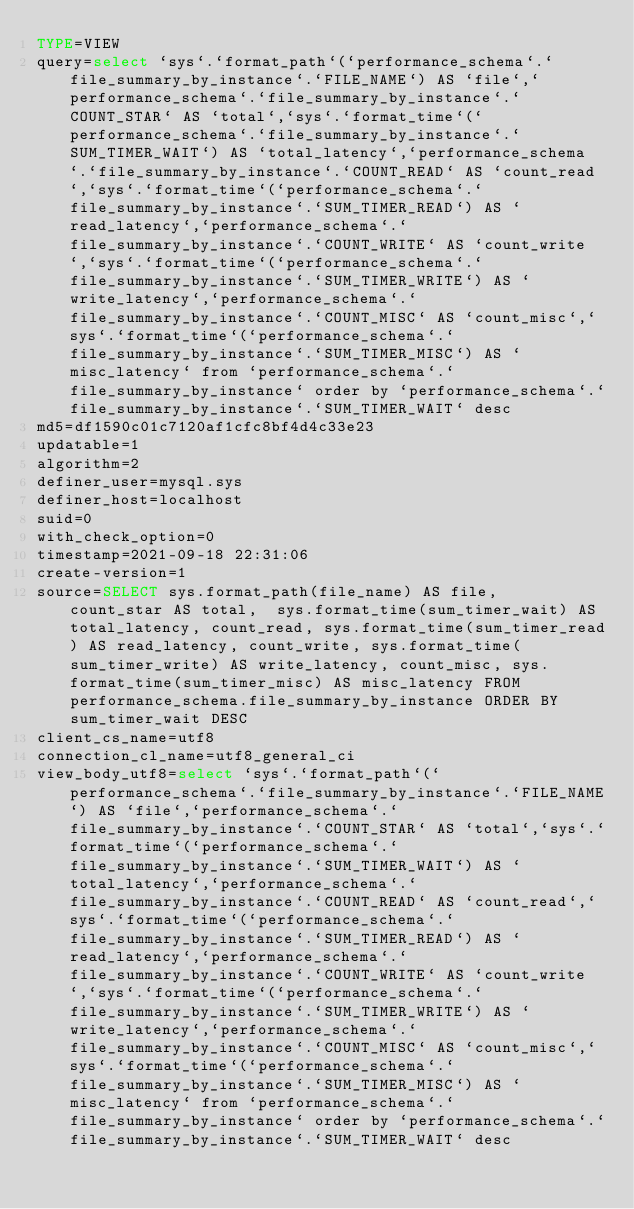<code> <loc_0><loc_0><loc_500><loc_500><_VisualBasic_>TYPE=VIEW
query=select `sys`.`format_path`(`performance_schema`.`file_summary_by_instance`.`FILE_NAME`) AS `file`,`performance_schema`.`file_summary_by_instance`.`COUNT_STAR` AS `total`,`sys`.`format_time`(`performance_schema`.`file_summary_by_instance`.`SUM_TIMER_WAIT`) AS `total_latency`,`performance_schema`.`file_summary_by_instance`.`COUNT_READ` AS `count_read`,`sys`.`format_time`(`performance_schema`.`file_summary_by_instance`.`SUM_TIMER_READ`) AS `read_latency`,`performance_schema`.`file_summary_by_instance`.`COUNT_WRITE` AS `count_write`,`sys`.`format_time`(`performance_schema`.`file_summary_by_instance`.`SUM_TIMER_WRITE`) AS `write_latency`,`performance_schema`.`file_summary_by_instance`.`COUNT_MISC` AS `count_misc`,`sys`.`format_time`(`performance_schema`.`file_summary_by_instance`.`SUM_TIMER_MISC`) AS `misc_latency` from `performance_schema`.`file_summary_by_instance` order by `performance_schema`.`file_summary_by_instance`.`SUM_TIMER_WAIT` desc
md5=df1590c01c7120af1cfc8bf4d4c33e23
updatable=1
algorithm=2
definer_user=mysql.sys
definer_host=localhost
suid=0
with_check_option=0
timestamp=2021-09-18 22:31:06
create-version=1
source=SELECT sys.format_path(file_name) AS file,  count_star AS total,  sys.format_time(sum_timer_wait) AS total_latency, count_read, sys.format_time(sum_timer_read) AS read_latency, count_write, sys.format_time(sum_timer_write) AS write_latency, count_misc, sys.format_time(sum_timer_misc) AS misc_latency FROM performance_schema.file_summary_by_instance ORDER BY sum_timer_wait DESC
client_cs_name=utf8
connection_cl_name=utf8_general_ci
view_body_utf8=select `sys`.`format_path`(`performance_schema`.`file_summary_by_instance`.`FILE_NAME`) AS `file`,`performance_schema`.`file_summary_by_instance`.`COUNT_STAR` AS `total`,`sys`.`format_time`(`performance_schema`.`file_summary_by_instance`.`SUM_TIMER_WAIT`) AS `total_latency`,`performance_schema`.`file_summary_by_instance`.`COUNT_READ` AS `count_read`,`sys`.`format_time`(`performance_schema`.`file_summary_by_instance`.`SUM_TIMER_READ`) AS `read_latency`,`performance_schema`.`file_summary_by_instance`.`COUNT_WRITE` AS `count_write`,`sys`.`format_time`(`performance_schema`.`file_summary_by_instance`.`SUM_TIMER_WRITE`) AS `write_latency`,`performance_schema`.`file_summary_by_instance`.`COUNT_MISC` AS `count_misc`,`sys`.`format_time`(`performance_schema`.`file_summary_by_instance`.`SUM_TIMER_MISC`) AS `misc_latency` from `performance_schema`.`file_summary_by_instance` order by `performance_schema`.`file_summary_by_instance`.`SUM_TIMER_WAIT` desc
</code> 